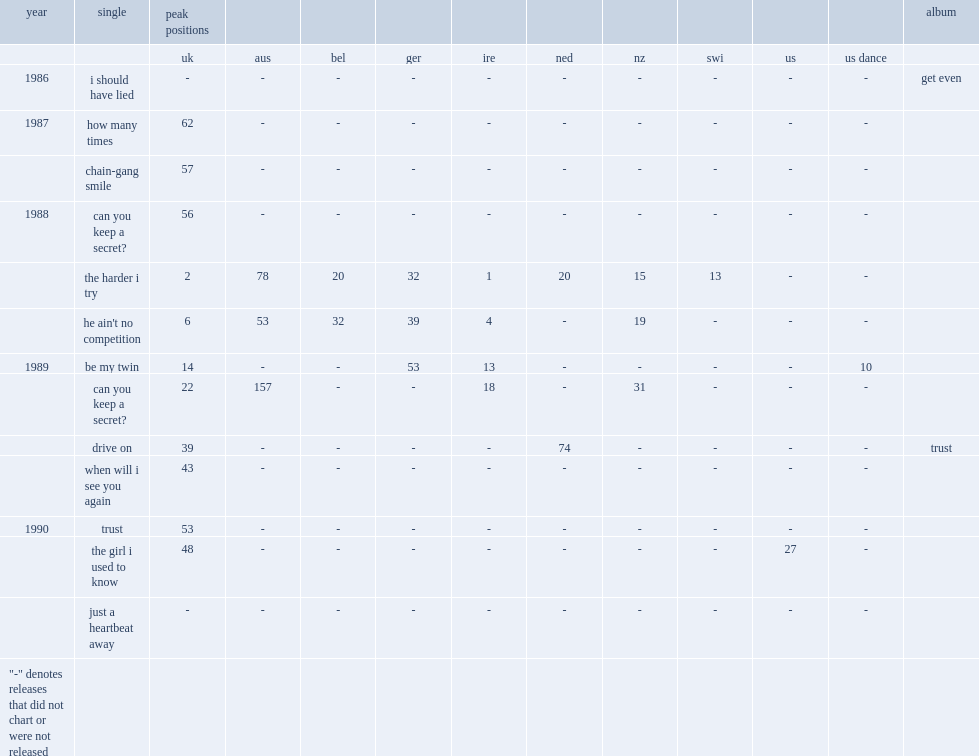In 1989, what is the peak position for the single "drive on" in the uk, from their second album trust? 39.0. 